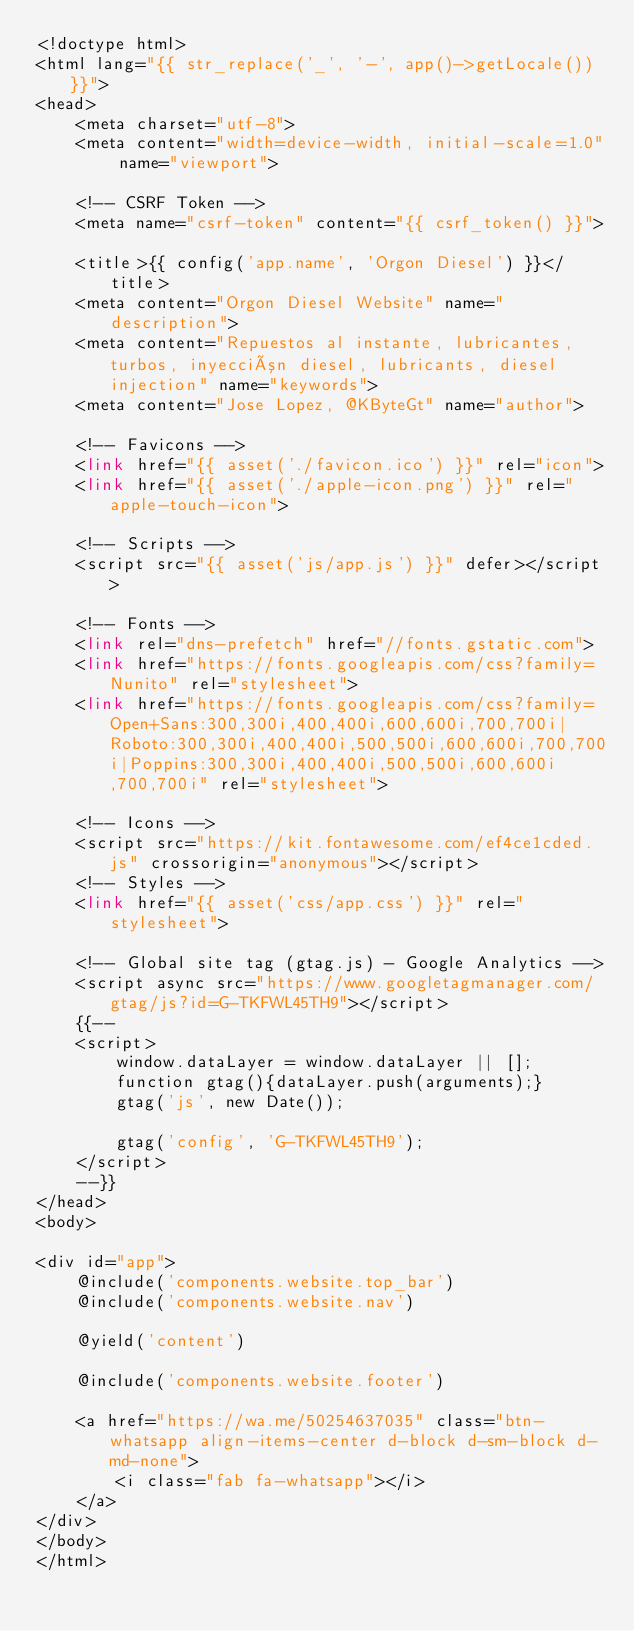<code> <loc_0><loc_0><loc_500><loc_500><_PHP_><!doctype html>
<html lang="{{ str_replace('_', '-', app()->getLocale()) }}">
<head>
    <meta charset="utf-8">
    <meta content="width=device-width, initial-scale=1.0" name="viewport">

    <!-- CSRF Token -->
    <meta name="csrf-token" content="{{ csrf_token() }}">

    <title>{{ config('app.name', 'Orgon Diesel') }}</title>
    <meta content="Orgon Diesel Website" name="description">
    <meta content="Repuestos al instante, lubricantes, turbos, inyección diesel, lubricants, diesel injection" name="keywords">
    <meta content="Jose Lopez, @KByteGt" name="author">

    <!-- Favicons -->
    <link href="{{ asset('./favicon.ico') }}" rel="icon">
    <link href="{{ asset('./apple-icon.png') }}" rel="apple-touch-icon">

    <!-- Scripts -->
    <script src="{{ asset('js/app.js') }}" defer></script>

    <!-- Fonts -->
    <link rel="dns-prefetch" href="//fonts.gstatic.com">
    <link href="https://fonts.googleapis.com/css?family=Nunito" rel="stylesheet">
    <link href="https://fonts.googleapis.com/css?family=Open+Sans:300,300i,400,400i,600,600i,700,700i|Roboto:300,300i,400,400i,500,500i,600,600i,700,700i|Poppins:300,300i,400,400i,500,500i,600,600i,700,700i" rel="stylesheet">

    <!-- Icons -->
    <script src="https://kit.fontawesome.com/ef4ce1cded.js" crossorigin="anonymous"></script>
    <!-- Styles -->
    <link href="{{ asset('css/app.css') }}" rel="stylesheet">

    <!-- Global site tag (gtag.js) - Google Analytics -->
    <script async src="https://www.googletagmanager.com/gtag/js?id=G-TKFWL45TH9"></script>
    {{--
    <script>
        window.dataLayer = window.dataLayer || [];
        function gtag(){dataLayer.push(arguments);}
        gtag('js', new Date());

        gtag('config', 'G-TKFWL45TH9');
    </script>
    --}}
</head>
<body>

<div id="app">
    @include('components.website.top_bar')
    @include('components.website.nav')

    @yield('content')

    @include('components.website.footer')

    <a href="https://wa.me/50254637035" class="btn-whatsapp align-items-center d-block d-sm-block d-md-none">
        <i class="fab fa-whatsapp"></i>
    </a>
</div>
</body>
</html>
</code> 